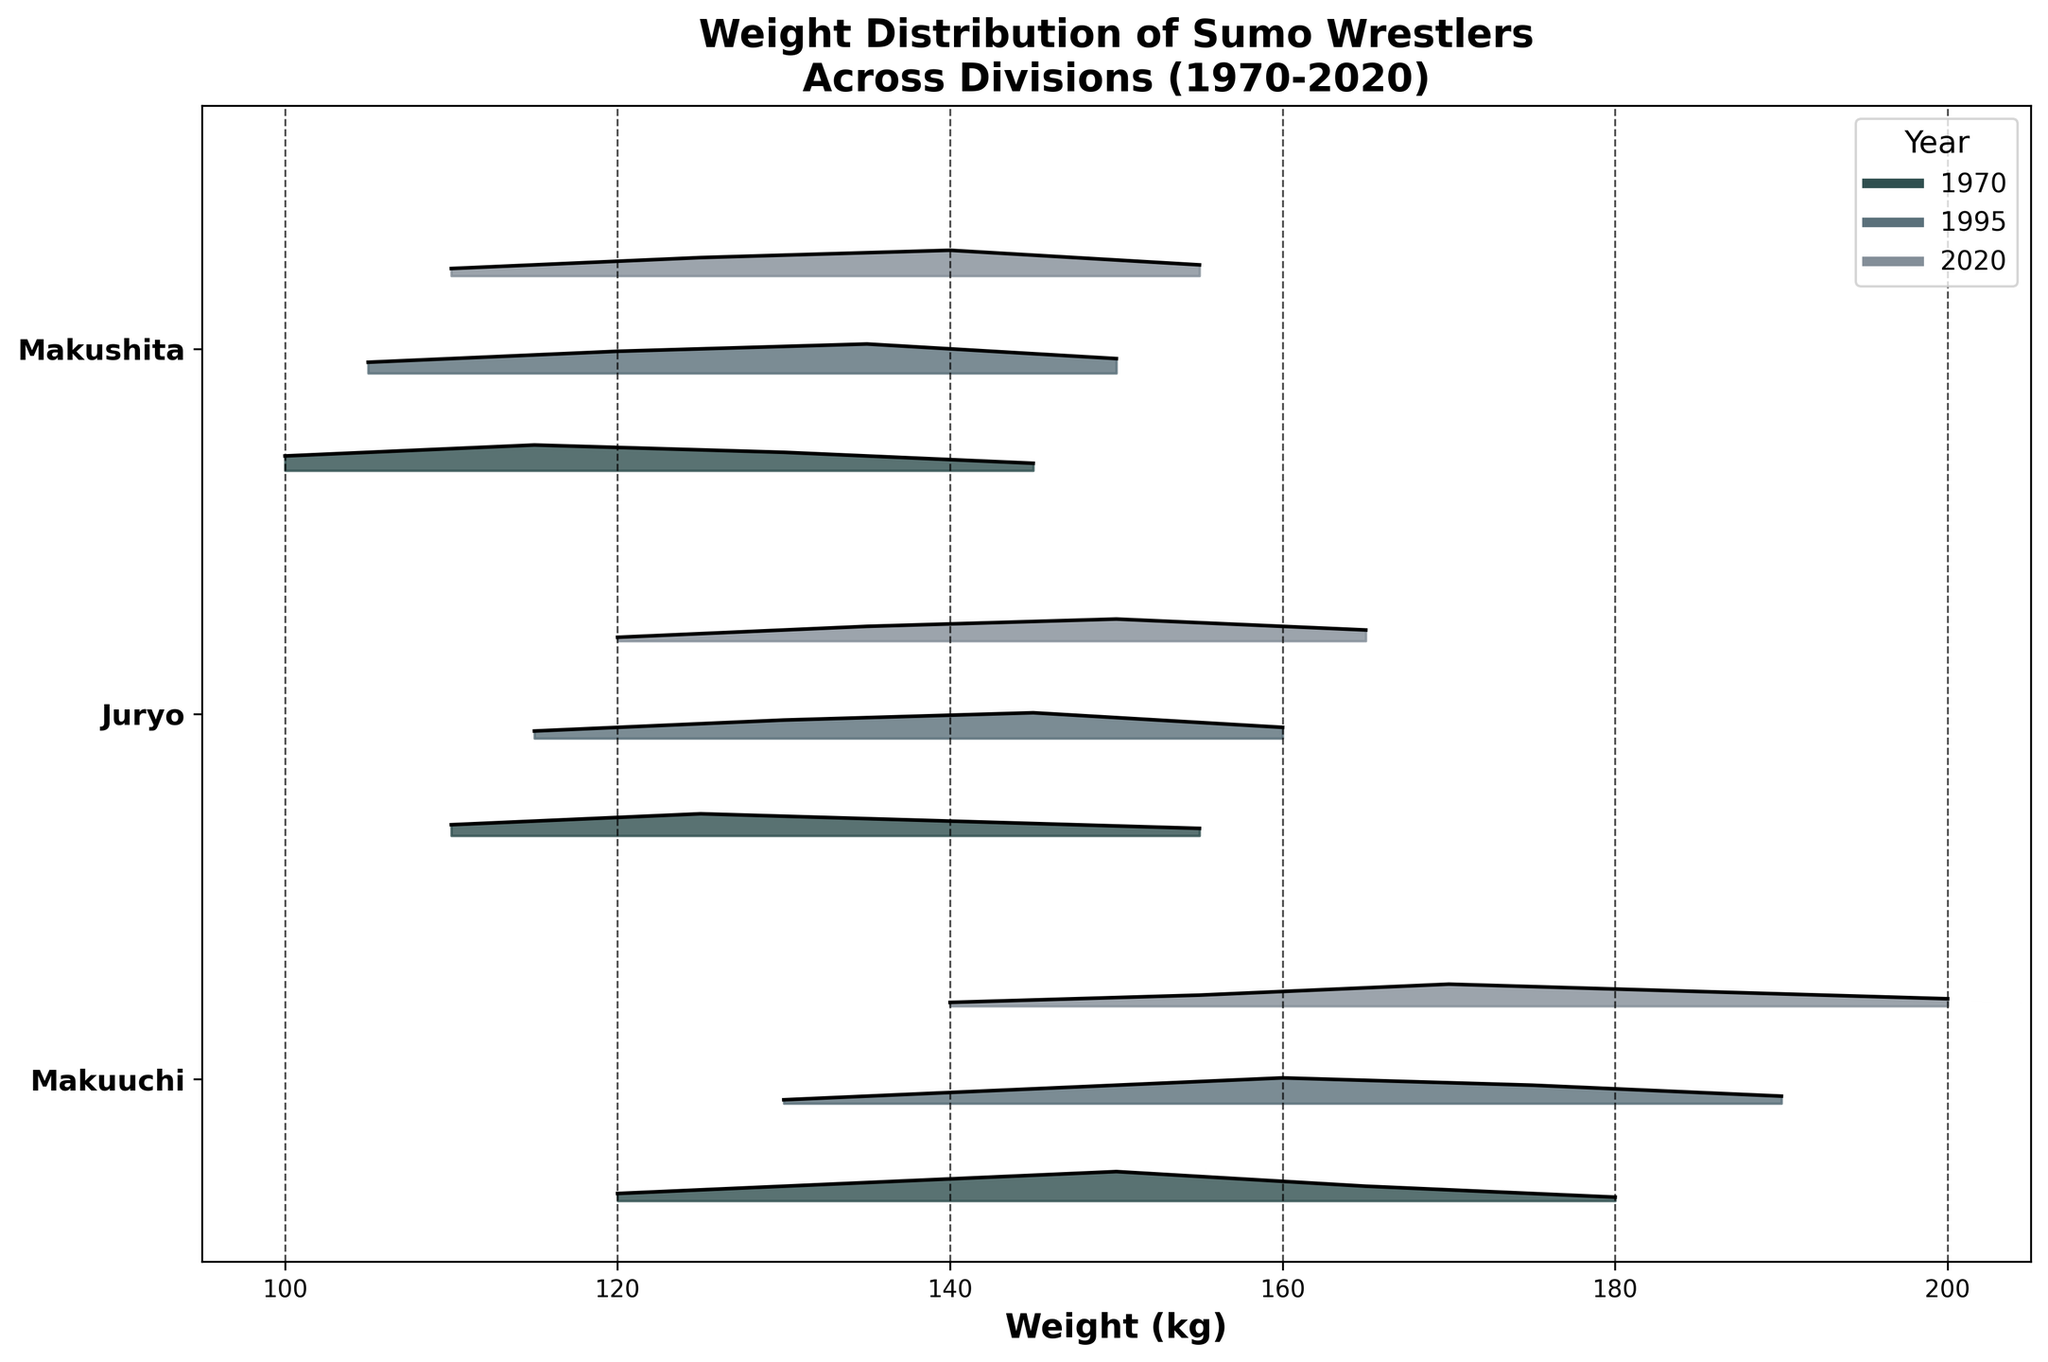Which division names are displayed on the plot? The y-axis labels indicate the division names. The y-ticks are labeled with the divisions' names.
Answer: Makuuchi, Juryo, Makushita What is the heaviest weight shown for the Makuuchi division in 2020? Look for the maximum x-axis value under the 'Makuuchi' division for the year 2020. This is indicated by the rightmost point on the x-axis for that specific year and division.
Answer: 200 kg Which year has the darkest shade for each division? The darkest shade on the graph corresponds to the earliest year, 1970, in the colormap used. This can be inferred by looking at the legend, which associates darker colors with earlier years.
Answer: 1970 How do the weight distributions of the Makuuchi division change from 1970 to 1995? Observe the shapes and x-axis ranges of the density plots for the Makuuchi division between 1970 and 1995. Compare the locations and heights of the peaks of each plot.
Answer: The weight distributions shift slightly to higher weights from 1970 to 1995, with the peak densities moving from 150 kg to 160 kg In which division and year is the weight of 145 kg the most common? Identify the year and division where the height of the plot is highest at the weight of 145 kg on the x-axis.
Answer: Juryo in 1995 Which division shows the least variance in weights in 2020? Look at the spread and height of the density plots for 2020 in each division. A tighter, higher peak indicates less variance.
Answer: Makushita Comparing 1995 to 2020, which division shows an increase in the average weight of wrestlers? Analyze the shift in the center of the weight distributions from 1995 to 2020 for each division. The division whose center moves to the right indicates an increase.
Answer: Makuuchi and Makushita Which division has the most fluctuating weights over the years? Observe the Ridgeline plot for each division across the years. The division with the most changes in the shape, peak densisity, and spread indicates more fluctuation.
Answer: Makuuchi What trend can you observe in the Makushita division's weight distribution from 1970 to 2020? Look at the density plots of the Makushita division over the years. Identify any consistent increases or decreases in peak positions or spread.
Answer: Increasing weight trend from 130 kg in 1970 to 140 kg in 2020 